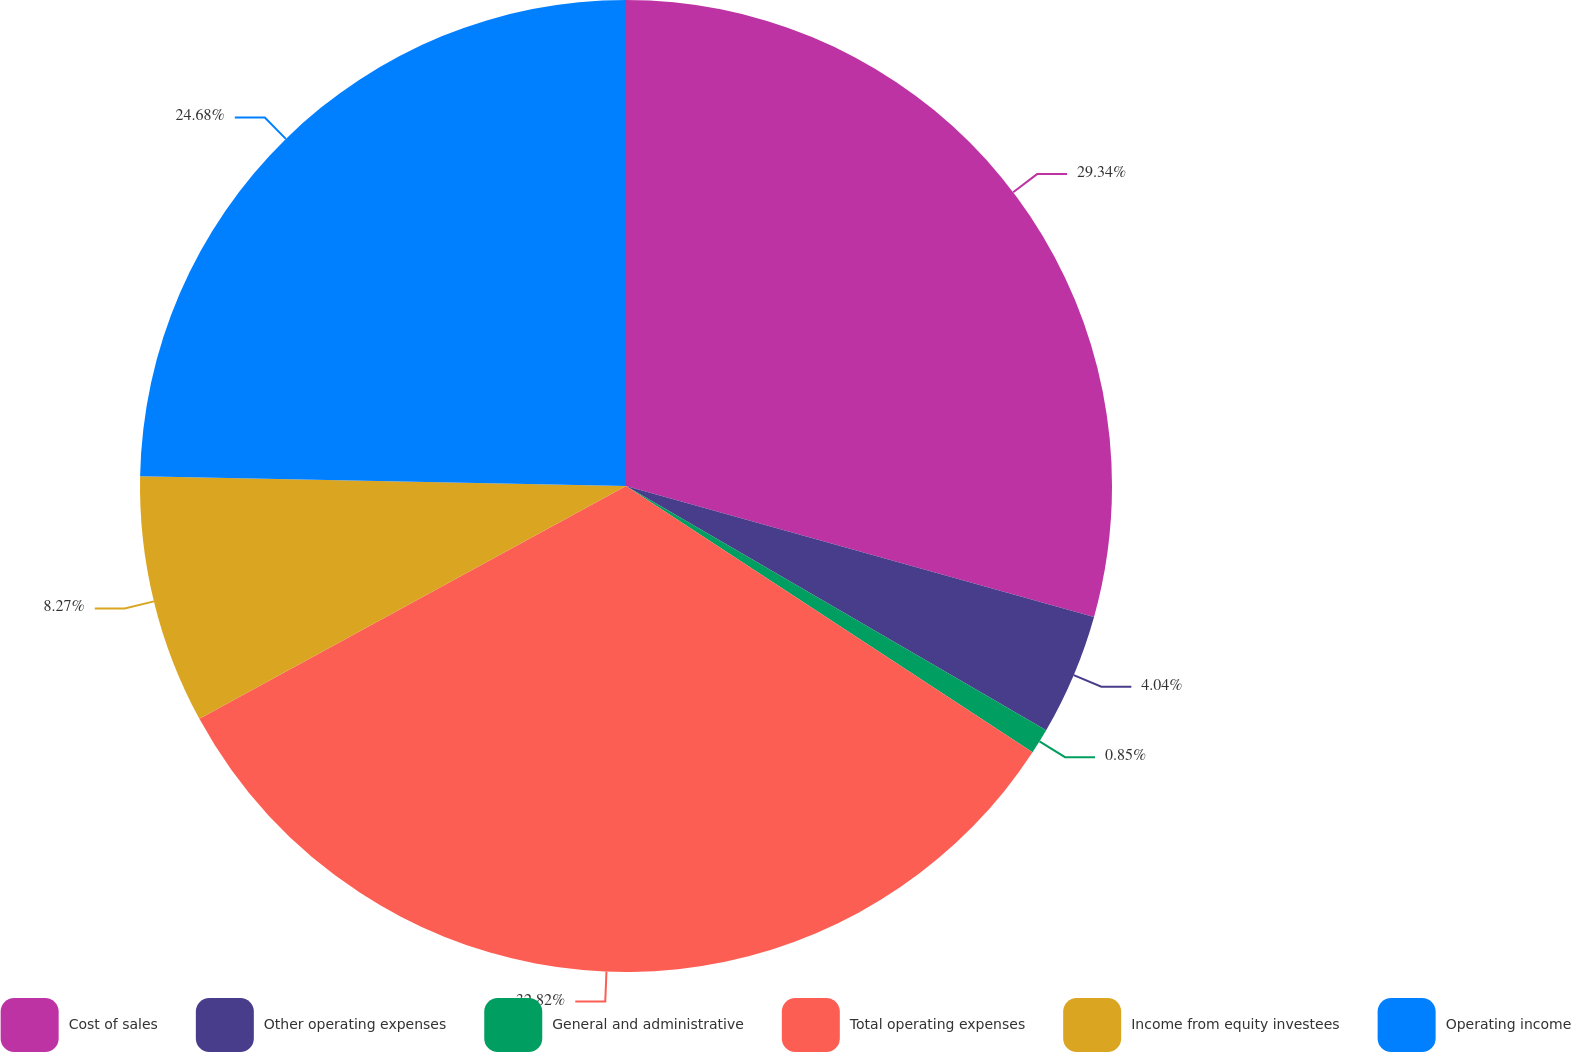<chart> <loc_0><loc_0><loc_500><loc_500><pie_chart><fcel>Cost of sales<fcel>Other operating expenses<fcel>General and administrative<fcel>Total operating expenses<fcel>Income from equity investees<fcel>Operating income<nl><fcel>29.34%<fcel>4.04%<fcel>0.85%<fcel>32.82%<fcel>8.27%<fcel>24.68%<nl></chart> 